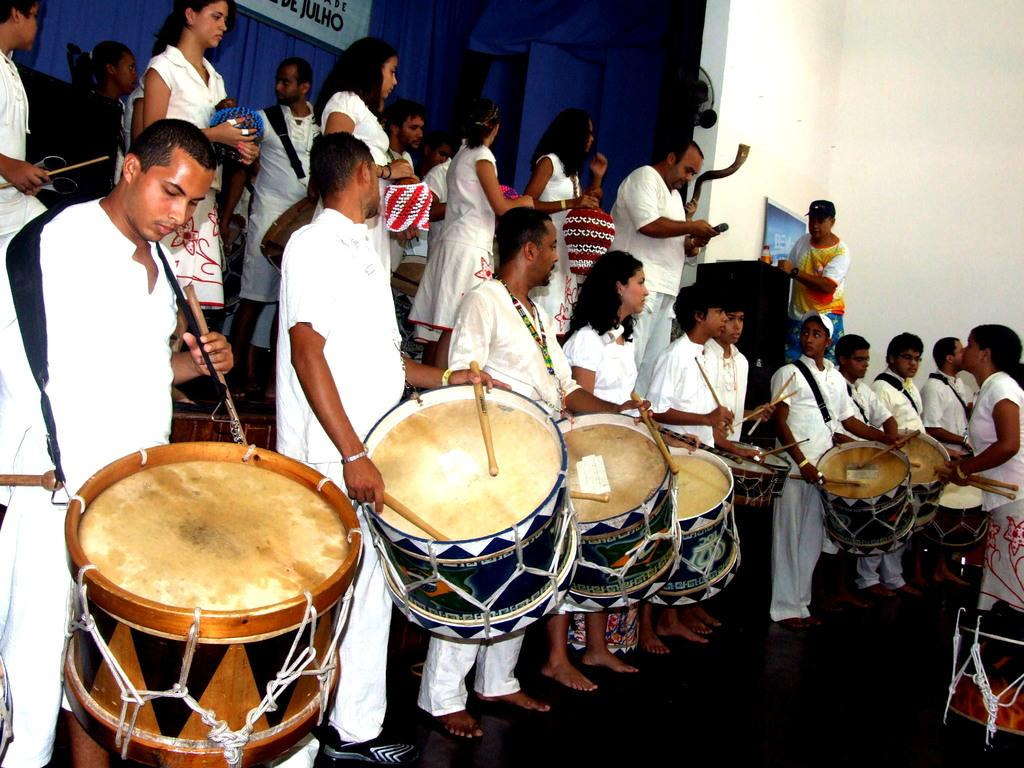How many people are in the image? There is a group of people in the image. What are the people in the image doing? The people are standing, and some of them are playing drums. What type of texture can be seen on the drawer in the image? There is no drawer present in the image. How many trains are visible in the image? There are no trains visible in the image. 